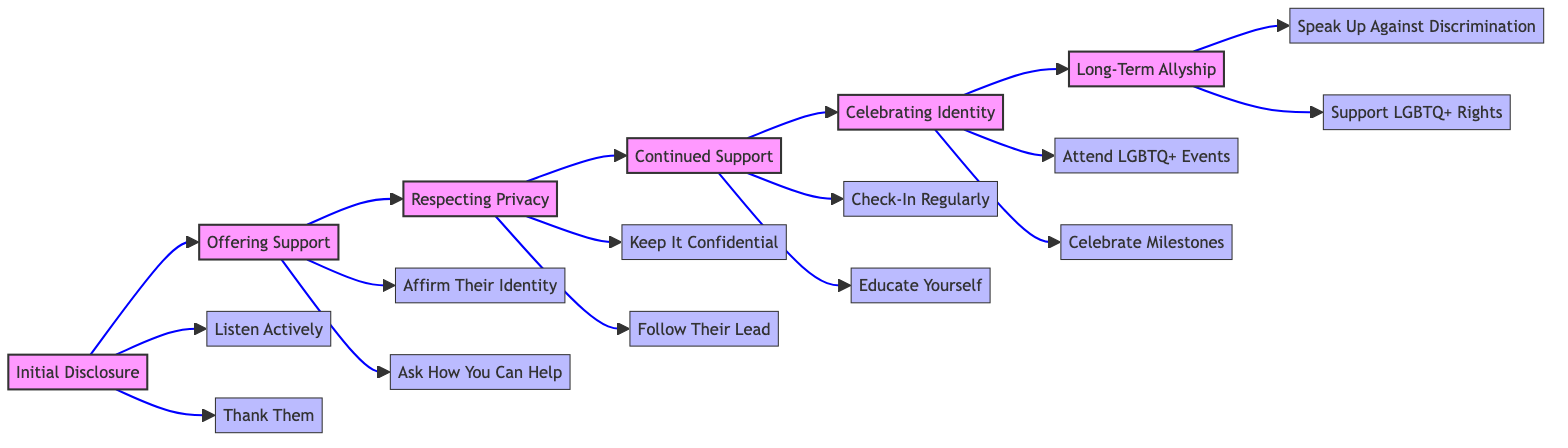What is the first step in supporting a friend through coming out? The first step is "Initial Disclosure," where the friend decides to share their LGBTQ+ identity. This node is labeled as step one in the diagram and outlines the beginning of the support process.
Answer: Initial Disclosure How many main steps are there in the flowchart? The flowchart consists of six main steps, as shown by the numbered nodes from one to six, representing the progression of support throughout the coming out process.
Answer: Six What action is taken after the "Initial Disclosure"? After "Initial Disclosure," the next action is "Offering Support," as indicated by the arrow pointing from the first step to the second step in the diagram.
Answer: Offering Support Which action emphasizes the importance of confidentiality? The action that emphasizes confidentiality is "Keep It Confidential," part of the "Respecting Privacy" node, which is dedicated to ensuring the friend's story remains safeguarded.
Answer: Keep It Confidential What follows "Continued Support" in the flowchart? "Celebrating Identity" follows "Continued Support," as indicated by the flow of arrows leading from the fourth step to the fifth step in the diagram, implying the next action in the support process.
Answer: Celebrating Identity Which action encourages personal engagement in LGBTQ+ celebrations? The action that encourages personal engagement is "Attend LGBTQ+ Events," which is linked to the "Celebrating Identity" step and highlights the importance of participation in events like Pride.
Answer: Attend LGBTQ+ Events How does a friend show long-term commitment to allyship? A friend shows long-term commitment by engaging in actions like "Speak Up Against Discrimination" and "Support LGBTQ+ Rights," which are the actions listed under the "Long-Term Allyship" node.
Answer: Speak Up Against Discrimination What is the final node in the flowchart? The final node in the flowchart is "Long-Term Allyship," which represents the ongoing commitment to support the LGBTQ+ community. This node concludes the series of supportive actions presented.
Answer: Long-Term Allyship 